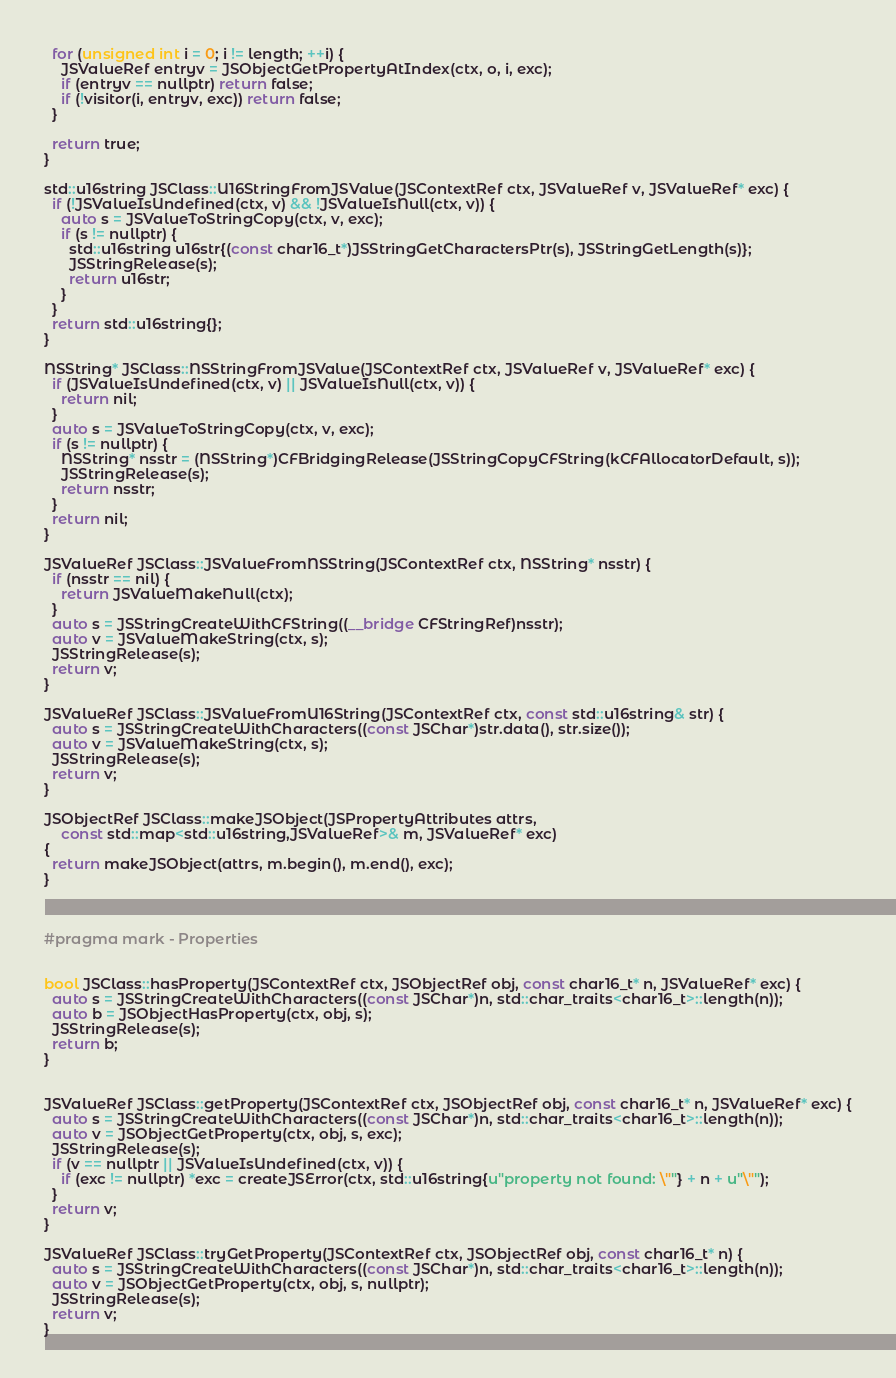Convert code to text. <code><loc_0><loc_0><loc_500><loc_500><_ObjectiveC_>  for (unsigned int i = 0; i != length; ++i) {
    JSValueRef entryv = JSObjectGetPropertyAtIndex(ctx, o, i, exc);
    if (entryv == nullptr) return false;
    if (!visitor(i, entryv, exc)) return false;
  }
  
  return true;
}

std::u16string JSClass::U16StringFromJSValue(JSContextRef ctx, JSValueRef v, JSValueRef* exc) {
  if (!JSValueIsUndefined(ctx, v) && !JSValueIsNull(ctx, v)) {
    auto s = JSValueToStringCopy(ctx, v, exc);
    if (s != nullptr) {
      std::u16string u16str{(const char16_t*)JSStringGetCharactersPtr(s), JSStringGetLength(s)};
      JSStringRelease(s);
      return u16str;
    }
  }
  return std::u16string{};
}

NSString* JSClass::NSStringFromJSValue(JSContextRef ctx, JSValueRef v, JSValueRef* exc) {
  if (JSValueIsUndefined(ctx, v) || JSValueIsNull(ctx, v)) {
    return nil;
  }
  auto s = JSValueToStringCopy(ctx, v, exc);
  if (s != nullptr) {
    NSString* nsstr = (NSString*)CFBridgingRelease(JSStringCopyCFString(kCFAllocatorDefault, s));
    JSStringRelease(s);
    return nsstr;
  }
  return nil;
}

JSValueRef JSClass::JSValueFromNSString(JSContextRef ctx, NSString* nsstr) {
  if (nsstr == nil) {
    return JSValueMakeNull(ctx);
  }
  auto s = JSStringCreateWithCFString((__bridge CFStringRef)nsstr);
  auto v = JSValueMakeString(ctx, s);
  JSStringRelease(s);
  return v;
}

JSValueRef JSClass::JSValueFromU16String(JSContextRef ctx, const std::u16string& str) {
  auto s = JSStringCreateWithCharacters((const JSChar*)str.data(), str.size());
  auto v = JSValueMakeString(ctx, s);
  JSStringRelease(s);
  return v;
}

JSObjectRef JSClass::makeJSObject(JSPropertyAttributes attrs,
    const std::map<std::u16string,JSValueRef>& m, JSValueRef* exc)
{
  return makeJSObject(attrs, m.begin(), m.end(), exc);
}



#pragma mark - Properties


bool JSClass::hasProperty(JSContextRef ctx, JSObjectRef obj, const char16_t* n, JSValueRef* exc) {
  auto s = JSStringCreateWithCharacters((const JSChar*)n, std::char_traits<char16_t>::length(n));
  auto b = JSObjectHasProperty(ctx, obj, s);
  JSStringRelease(s);
  return b;
}


JSValueRef JSClass::getProperty(JSContextRef ctx, JSObjectRef obj, const char16_t* n, JSValueRef* exc) {
  auto s = JSStringCreateWithCharacters((const JSChar*)n, std::char_traits<char16_t>::length(n));
  auto v = JSObjectGetProperty(ctx, obj, s, exc);
  JSStringRelease(s);
  if (v == nullptr || JSValueIsUndefined(ctx, v)) {
    if (exc != nullptr) *exc = createJSError(ctx, std::u16string{u"property not found: \""} + n + u"\"");
  }
  return v;
}

JSValueRef JSClass::tryGetProperty(JSContextRef ctx, JSObjectRef obj, const char16_t* n) {
  auto s = JSStringCreateWithCharacters((const JSChar*)n, std::char_traits<char16_t>::length(n));
  auto v = JSObjectGetProperty(ctx, obj, s, nullptr);
  JSStringRelease(s);
  return v;
}

</code> 